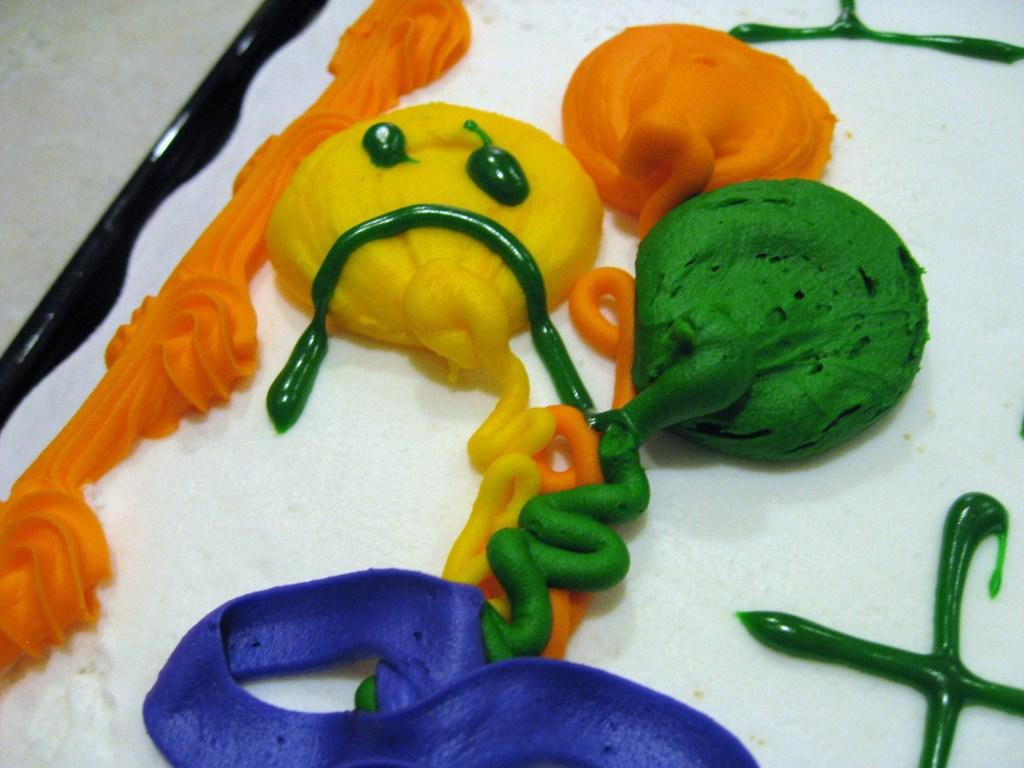What type of product is visible in the image? There are colorful creams in the image. What is the color of the surface on which the creams are placed? The creams are on a white surface. How many family members are present in the image? There is no family or family members present in the image; it only features colorful creams on a white surface. What part of the body is visible in the image? There are no body parts visible in the image; it only features colorful creams on a white surface. 